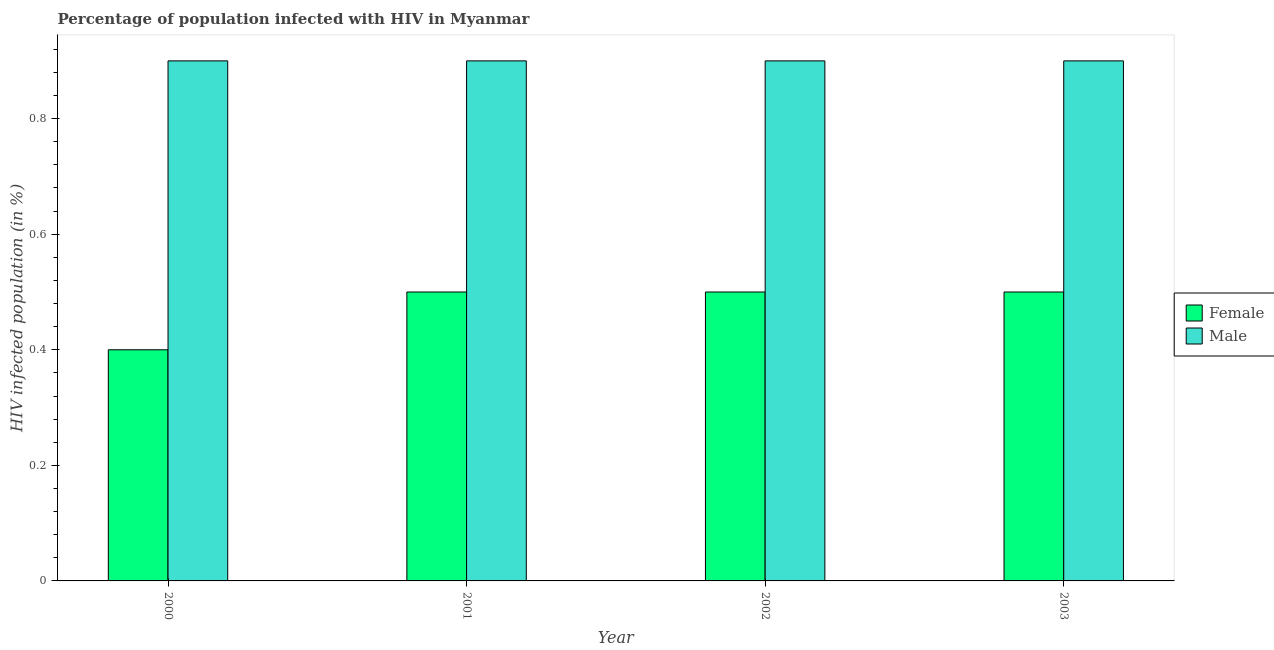How many groups of bars are there?
Make the answer very short. 4. Are the number of bars on each tick of the X-axis equal?
Ensure brevity in your answer.  Yes. How many bars are there on the 3rd tick from the left?
Your response must be concise. 2. What is the label of the 1st group of bars from the left?
Give a very brief answer. 2000. In how many cases, is the number of bars for a given year not equal to the number of legend labels?
Provide a short and direct response. 0. In which year was the percentage of females who are infected with hiv minimum?
Give a very brief answer. 2000. What is the total percentage of females who are infected with hiv in the graph?
Offer a terse response. 1.9. What is the difference between the percentage of males who are infected with hiv in 2000 and the percentage of females who are infected with hiv in 2003?
Give a very brief answer. 0. In the year 2001, what is the difference between the percentage of females who are infected with hiv and percentage of males who are infected with hiv?
Provide a short and direct response. 0. In how many years, is the percentage of females who are infected with hiv greater than 0.2 %?
Your response must be concise. 4. What is the ratio of the percentage of males who are infected with hiv in 2001 to that in 2002?
Offer a very short reply. 1. Is the percentage of females who are infected with hiv in 2001 less than that in 2002?
Provide a succinct answer. No. What is the difference between the highest and the second highest percentage of females who are infected with hiv?
Your answer should be compact. 0. What is the difference between the highest and the lowest percentage of females who are infected with hiv?
Provide a succinct answer. 0.1. In how many years, is the percentage of females who are infected with hiv greater than the average percentage of females who are infected with hiv taken over all years?
Provide a succinct answer. 3. What does the 1st bar from the right in 2001 represents?
Your answer should be compact. Male. How many bars are there?
Your answer should be very brief. 8. Are all the bars in the graph horizontal?
Make the answer very short. No. How many years are there in the graph?
Give a very brief answer. 4. Are the values on the major ticks of Y-axis written in scientific E-notation?
Keep it short and to the point. No. Does the graph contain any zero values?
Give a very brief answer. No. How many legend labels are there?
Ensure brevity in your answer.  2. What is the title of the graph?
Give a very brief answer. Percentage of population infected with HIV in Myanmar. Does "Secondary education" appear as one of the legend labels in the graph?
Keep it short and to the point. No. What is the label or title of the X-axis?
Ensure brevity in your answer.  Year. What is the label or title of the Y-axis?
Provide a short and direct response. HIV infected population (in %). What is the HIV infected population (in %) in Female in 2000?
Provide a succinct answer. 0.4. What is the HIV infected population (in %) of Male in 2000?
Offer a very short reply. 0.9. What is the HIV infected population (in %) in Male in 2001?
Offer a very short reply. 0.9. What is the HIV infected population (in %) of Female in 2002?
Ensure brevity in your answer.  0.5. What is the HIV infected population (in %) of Male in 2002?
Ensure brevity in your answer.  0.9. Across all years, what is the minimum HIV infected population (in %) in Male?
Your response must be concise. 0.9. What is the total HIV infected population (in %) in Female in the graph?
Provide a succinct answer. 1.9. What is the difference between the HIV infected population (in %) of Female in 2000 and that in 2001?
Keep it short and to the point. -0.1. What is the difference between the HIV infected population (in %) in Male in 2000 and that in 2001?
Give a very brief answer. 0. What is the difference between the HIV infected population (in %) of Female in 2000 and that in 2002?
Your answer should be compact. -0.1. What is the difference between the HIV infected population (in %) of Male in 2000 and that in 2002?
Your answer should be very brief. 0. What is the difference between the HIV infected population (in %) in Female in 2000 and that in 2003?
Provide a short and direct response. -0.1. What is the difference between the HIV infected population (in %) of Male in 2001 and that in 2002?
Your answer should be very brief. 0. What is the difference between the HIV infected population (in %) of Male in 2001 and that in 2003?
Keep it short and to the point. 0. What is the difference between the HIV infected population (in %) in Female in 2000 and the HIV infected population (in %) in Male in 2001?
Ensure brevity in your answer.  -0.5. What is the average HIV infected population (in %) in Female per year?
Offer a very short reply. 0.47. In the year 2002, what is the difference between the HIV infected population (in %) in Female and HIV infected population (in %) in Male?
Provide a short and direct response. -0.4. In the year 2003, what is the difference between the HIV infected population (in %) of Female and HIV infected population (in %) of Male?
Give a very brief answer. -0.4. What is the ratio of the HIV infected population (in %) in Male in 2000 to that in 2001?
Offer a very short reply. 1. What is the ratio of the HIV infected population (in %) of Female in 2000 to that in 2003?
Provide a succinct answer. 0.8. What is the difference between the highest and the second highest HIV infected population (in %) in Male?
Your response must be concise. 0. What is the difference between the highest and the lowest HIV infected population (in %) in Male?
Ensure brevity in your answer.  0. 